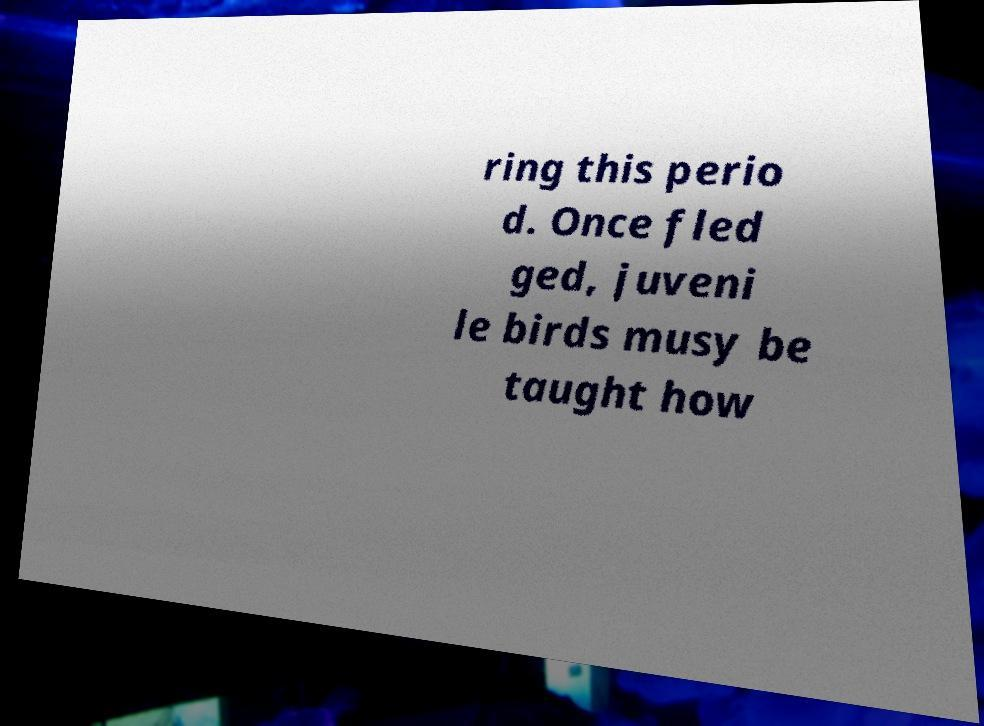I need the written content from this picture converted into text. Can you do that? ring this perio d. Once fled ged, juveni le birds musy be taught how 